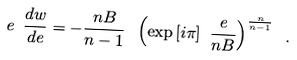Convert formula to latex. <formula><loc_0><loc_0><loc_500><loc_500>e \ \frac { d w } { d e } = - \frac { n B } { n - 1 } \ \left ( \exp { [ i \pi ] } \ \frac { e } { n B } \right ) ^ { \frac { n } { n - 1 } } \ .</formula> 